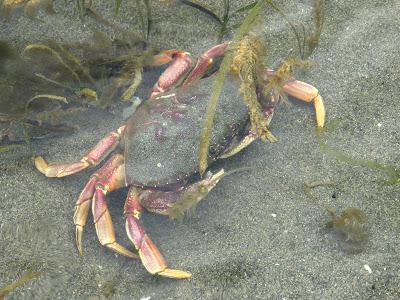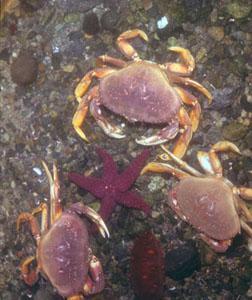The first image is the image on the left, the second image is the image on the right. Evaluate the accuracy of this statement regarding the images: "A single crab sits on the bottom of the water in each of the images.". Is it true? Answer yes or no. No. The first image is the image on the left, the second image is the image on the right. Considering the images on both sides, is "there are two crabs in the image pair" valid? Answer yes or no. No. 